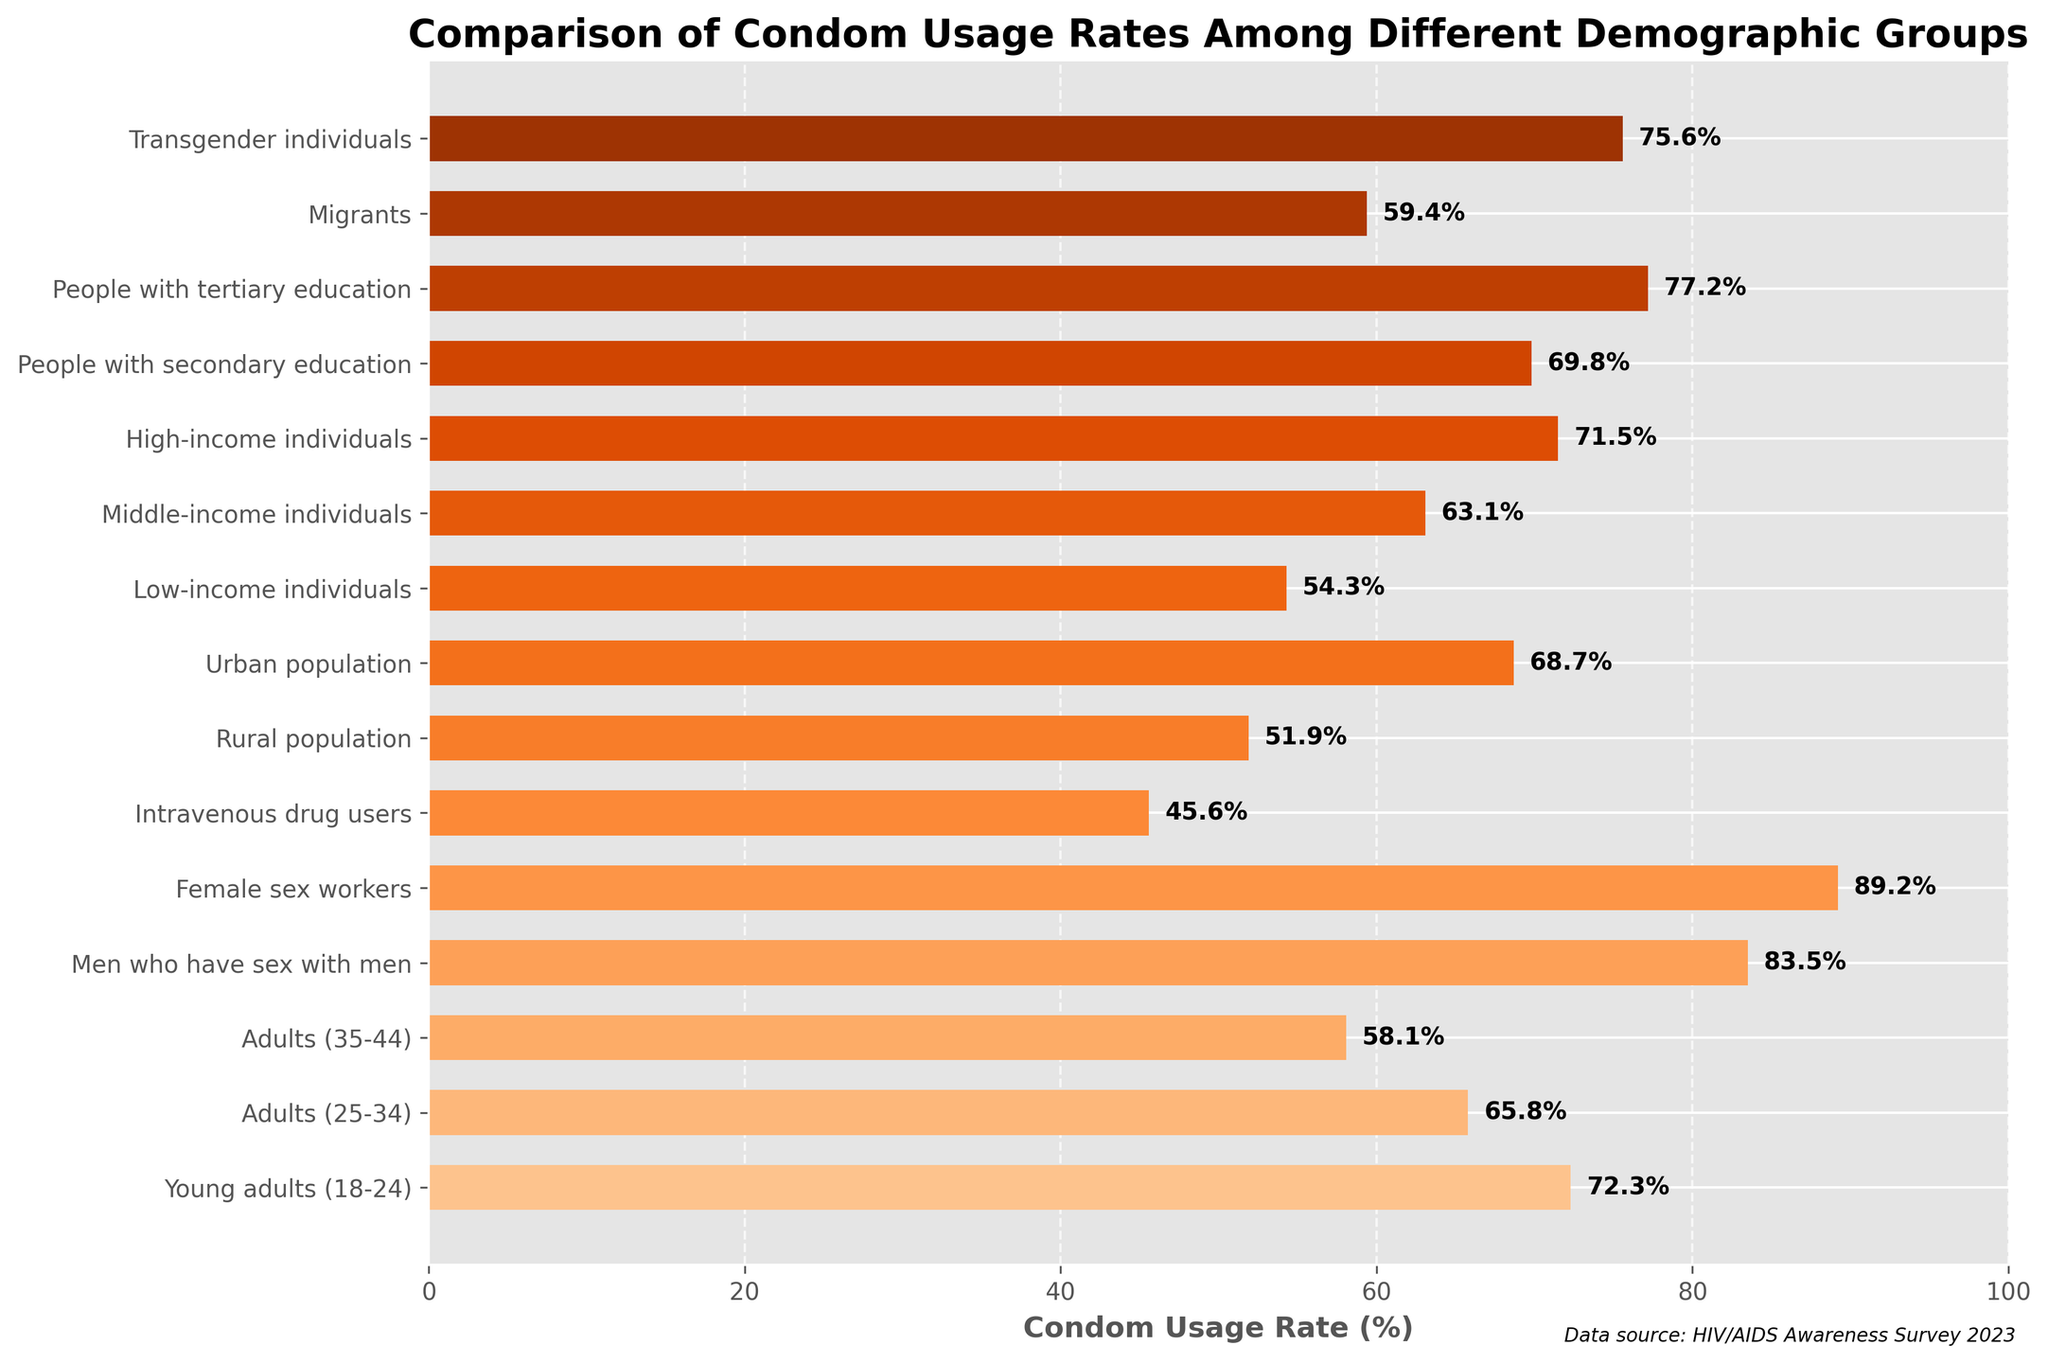Which demographic group has the highest condom usage rate? The bar chart shows that the group representing Female sex workers has the highest condom usage rate compared to others.
Answer: Female sex workers Which demographic group has the lowest condom usage rate? The bar representing Intravenous drug users is the shortest among all, indicating the lowest condom usage rate.
Answer: Intravenous drug users How does the condom usage rate of Young adults (18-24) compare to that of Middle-income individuals? The bar for Young adults (18-24) is taller than that for Middle-income individuals, indicating a higher condom usage rate.
Answer: Higher What is the average condom usage rate of Adults (25-34), Rural population, and Migrants? To find the average, sum the rates for Adults (25-34), Rural population, and Migrants and then divide by 3: (65.8 + 51.9 + 59.4) / 3 = 59.03.
Answer: 59.03 What is the median condom usage rate among the listed demographic groups? To find the median, list the rates in numerical order and find the middle value. Ordered rates: 45.6, 51.9, 54.3, 58.1, 59.4, 63.1, 65.8, 68.7, 69.8, 71.5, 72.3, 75.6, 77.2, 83.5, 89.2. The median value (middle) is 68.7
Answer: 68.7 Which demographic group has a condom usage rate just below that of Men who have sex with men? The bar for Transgender individuals is just below Men who have sex with men, indicating a slightly lower condom usage rate.
Answer: Transgender individuals How much higher is the condom usage rate for Female sex workers compared to Intravenous drug users? To find the difference, subtract the usage rate for Intravenous drug users from that of Female sex workers: 89.2 - 45.6 = 43.6.
Answer: 43.6 Between people with secondary education and people with tertiary education, which group has a higher condom usage rate? The bar for people with tertiary education is taller than that for people with secondary education, indicating a higher condom usage rate.
Answer: People with tertiary education What is the total of condom usage rates for the Rural population and Urban population? To find the total, sum the rates for Rural population and Urban population: 51.9 + 68.7 = 120.6.
Answer: 120.6 